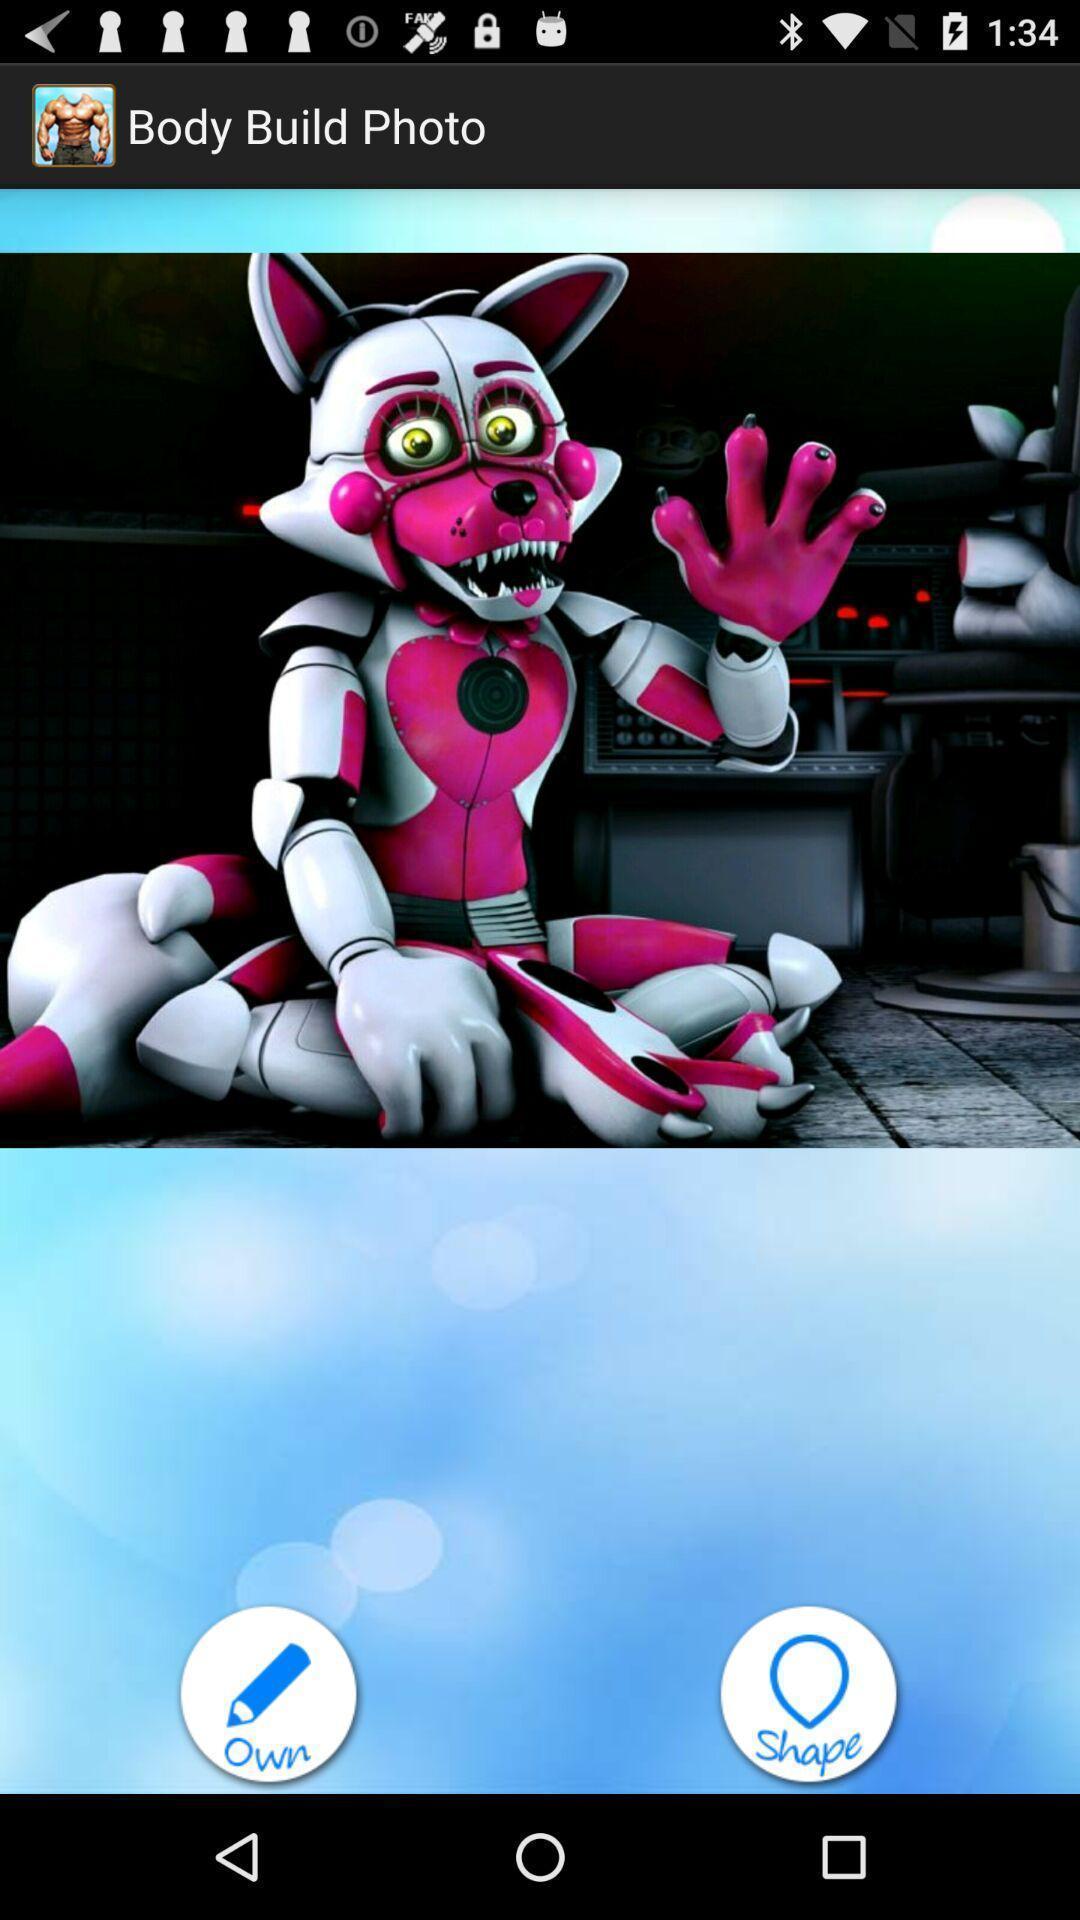Summarize the main components in this picture. Welcome page of a workout app. 